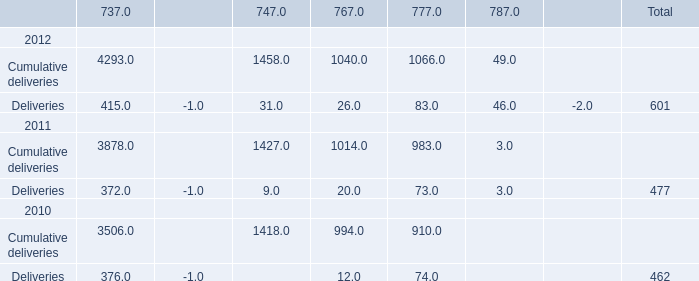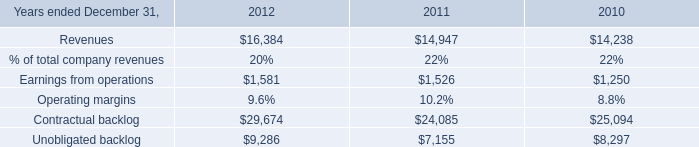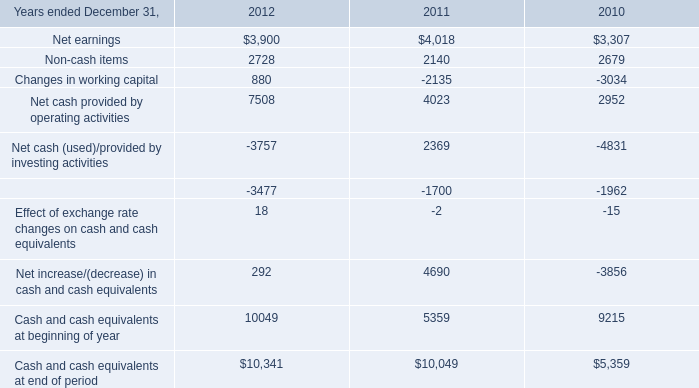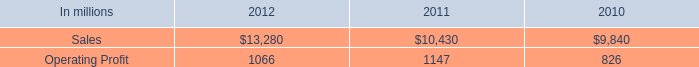What is the sum of Contractual backlog of 2011, Net cash provided by operating activities of 2011, and Cumulative deliveries 2010 of 737 ? 
Computations: ((24085.0 + 4023.0) + 3506.0)
Answer: 31614.0. In what year is Deliveries totally greater than 600? 
Answer: 2012. 